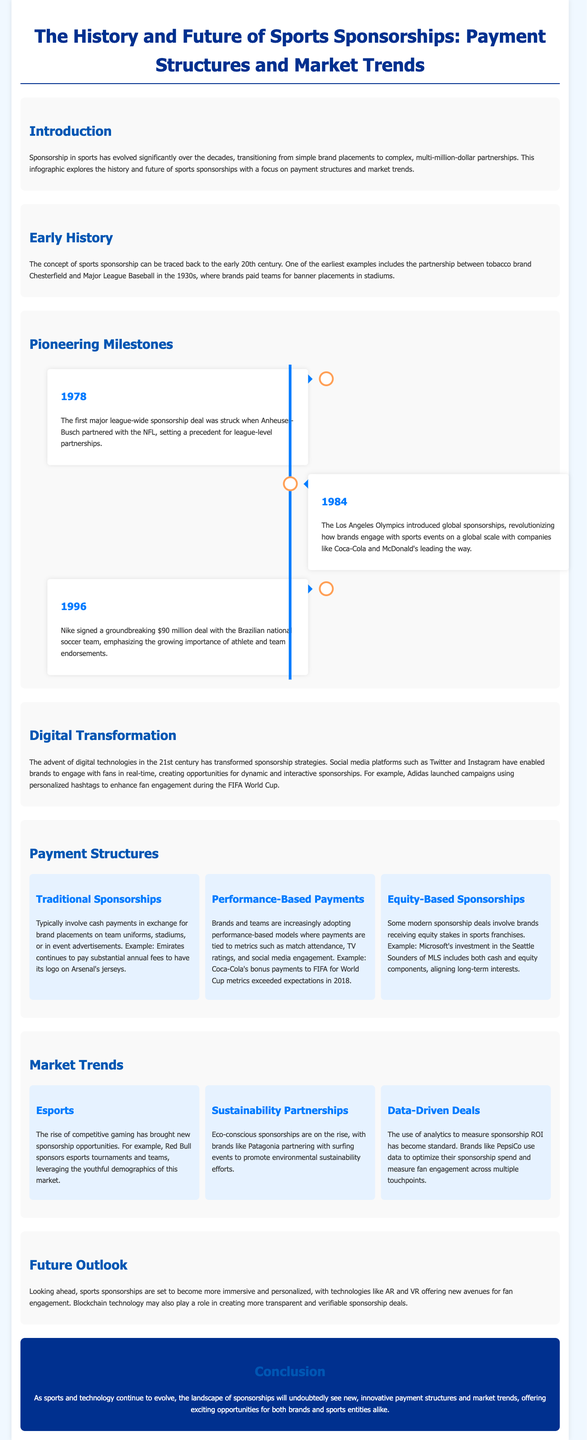What year was the first major league-wide sponsorship deal struck? The document states that the first major league-wide sponsorship deal was struck in 1978 with Anheuser-Busch and the NFL.
Answer: 1978 What significant event did the Los Angeles Olympics introduce in 1984? The document mentions that the Los Angeles Olympics introduced global sponsorships to sports events, revolutionizing brand engagement.
Answer: Global sponsorships What was the amount of the deal Nike signed in 1996 with the Brazilian national soccer team? According to the document, Nike signed a groundbreaking $90 million deal with the Brazilian national soccer team in 1996.
Answer: $90 million Which payment model ties brand payments to metrics like TV ratings? The document explains that performance-based payments tie brand payments to various metrics, creating a results-driven sponsorship dynamic.
Answer: Performance-Based Payments Which brand is mentioned as an example of a traditional sponsorship payment structure? The document refers to Emirates which pays substantial annual fees for brand placements on Arsenal's jerseys as an example.
Answer: Emirates What technology is anticipated to influence the future of sports sponsorships? The document forecasts that technologies like AR and VR will play a significant role in making sponsorships more immersive.
Answer: AR and VR Which brand uses data to optimize sponsorship spending and engagement? The document states that PepsiCo utilizes analytics to measure sponsorship ROI and optimize their spending.
Answer: PepsiCo What type of sponsorship is on the rise that promotes environmental efforts? According to the document, sustainability partnerships, exemplified by brands like Patagonia, are increasingly being adopted in sponsorships.
Answer: Sustainability Partnerships 